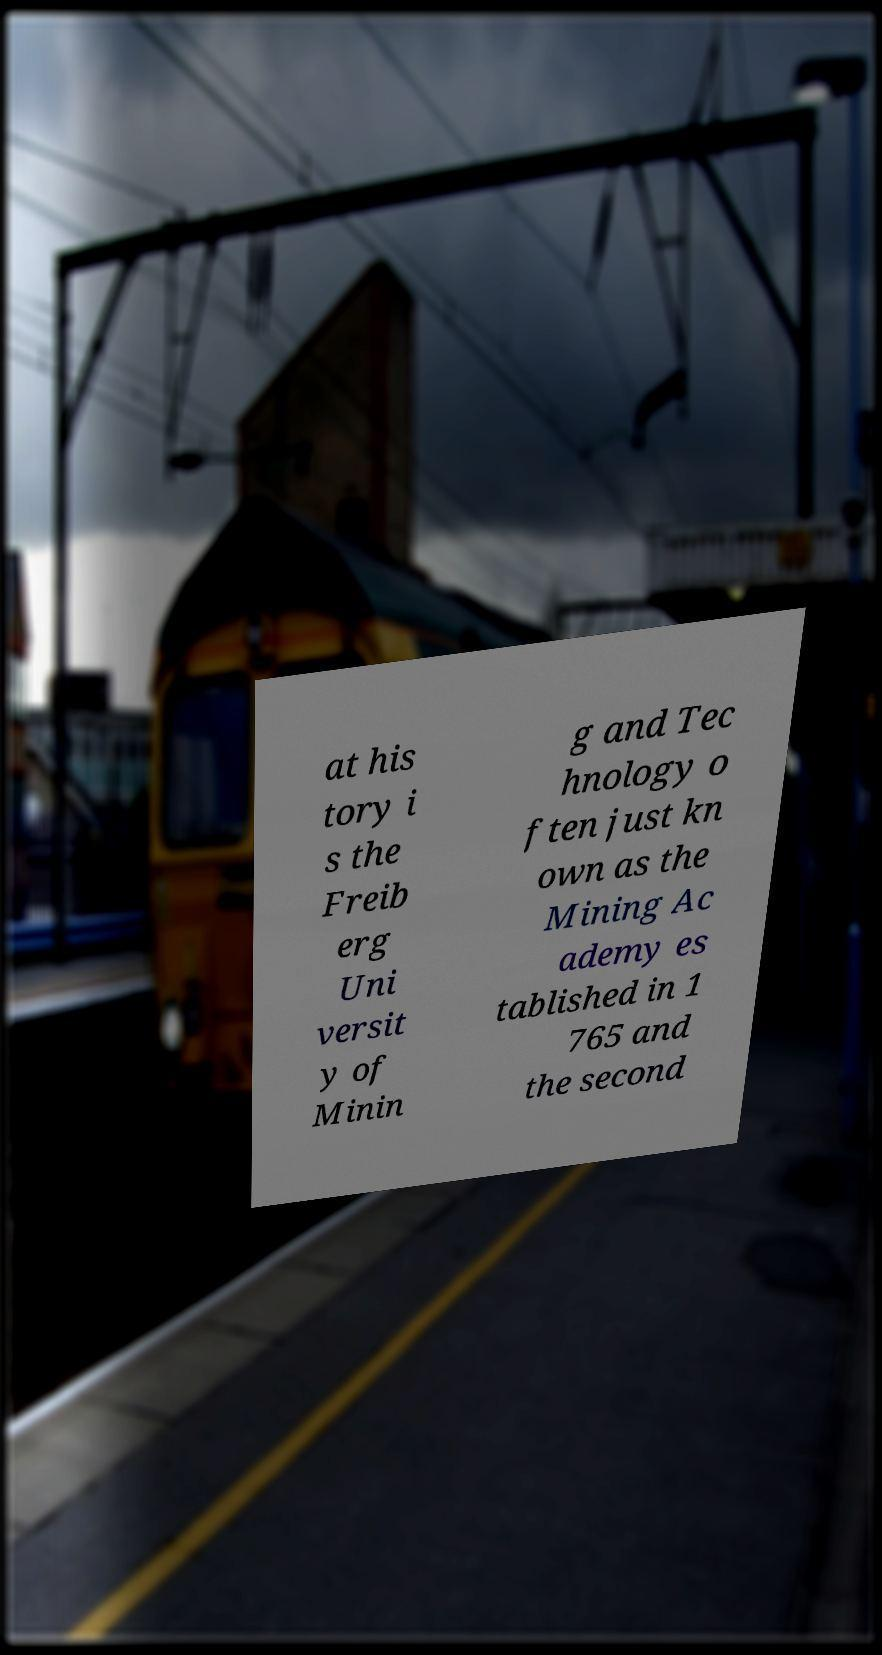There's text embedded in this image that I need extracted. Can you transcribe it verbatim? at his tory i s the Freib erg Uni versit y of Minin g and Tec hnology o ften just kn own as the Mining Ac ademy es tablished in 1 765 and the second 